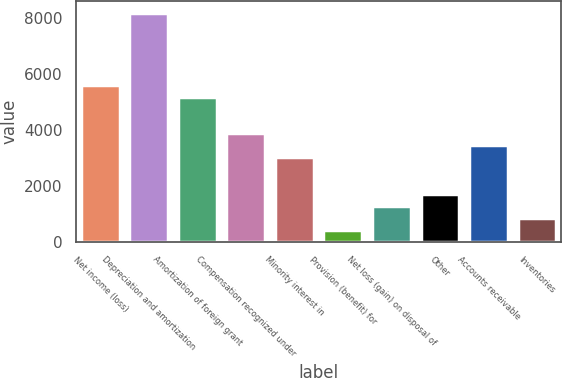Convert chart to OTSL. <chart><loc_0><loc_0><loc_500><loc_500><bar_chart><fcel>Net income (loss)<fcel>Depreciation and amortization<fcel>Amortization of foreign grant<fcel>Compensation recognized under<fcel>Minority interest in<fcel>Provision (benefit) for<fcel>Net loss (gain) on disposal of<fcel>Other<fcel>Accounts receivable<fcel>Inventories<nl><fcel>5593.6<fcel>8174.8<fcel>5163.4<fcel>3872.8<fcel>3012.4<fcel>431.2<fcel>1291.6<fcel>1721.8<fcel>3442.6<fcel>861.4<nl></chart> 